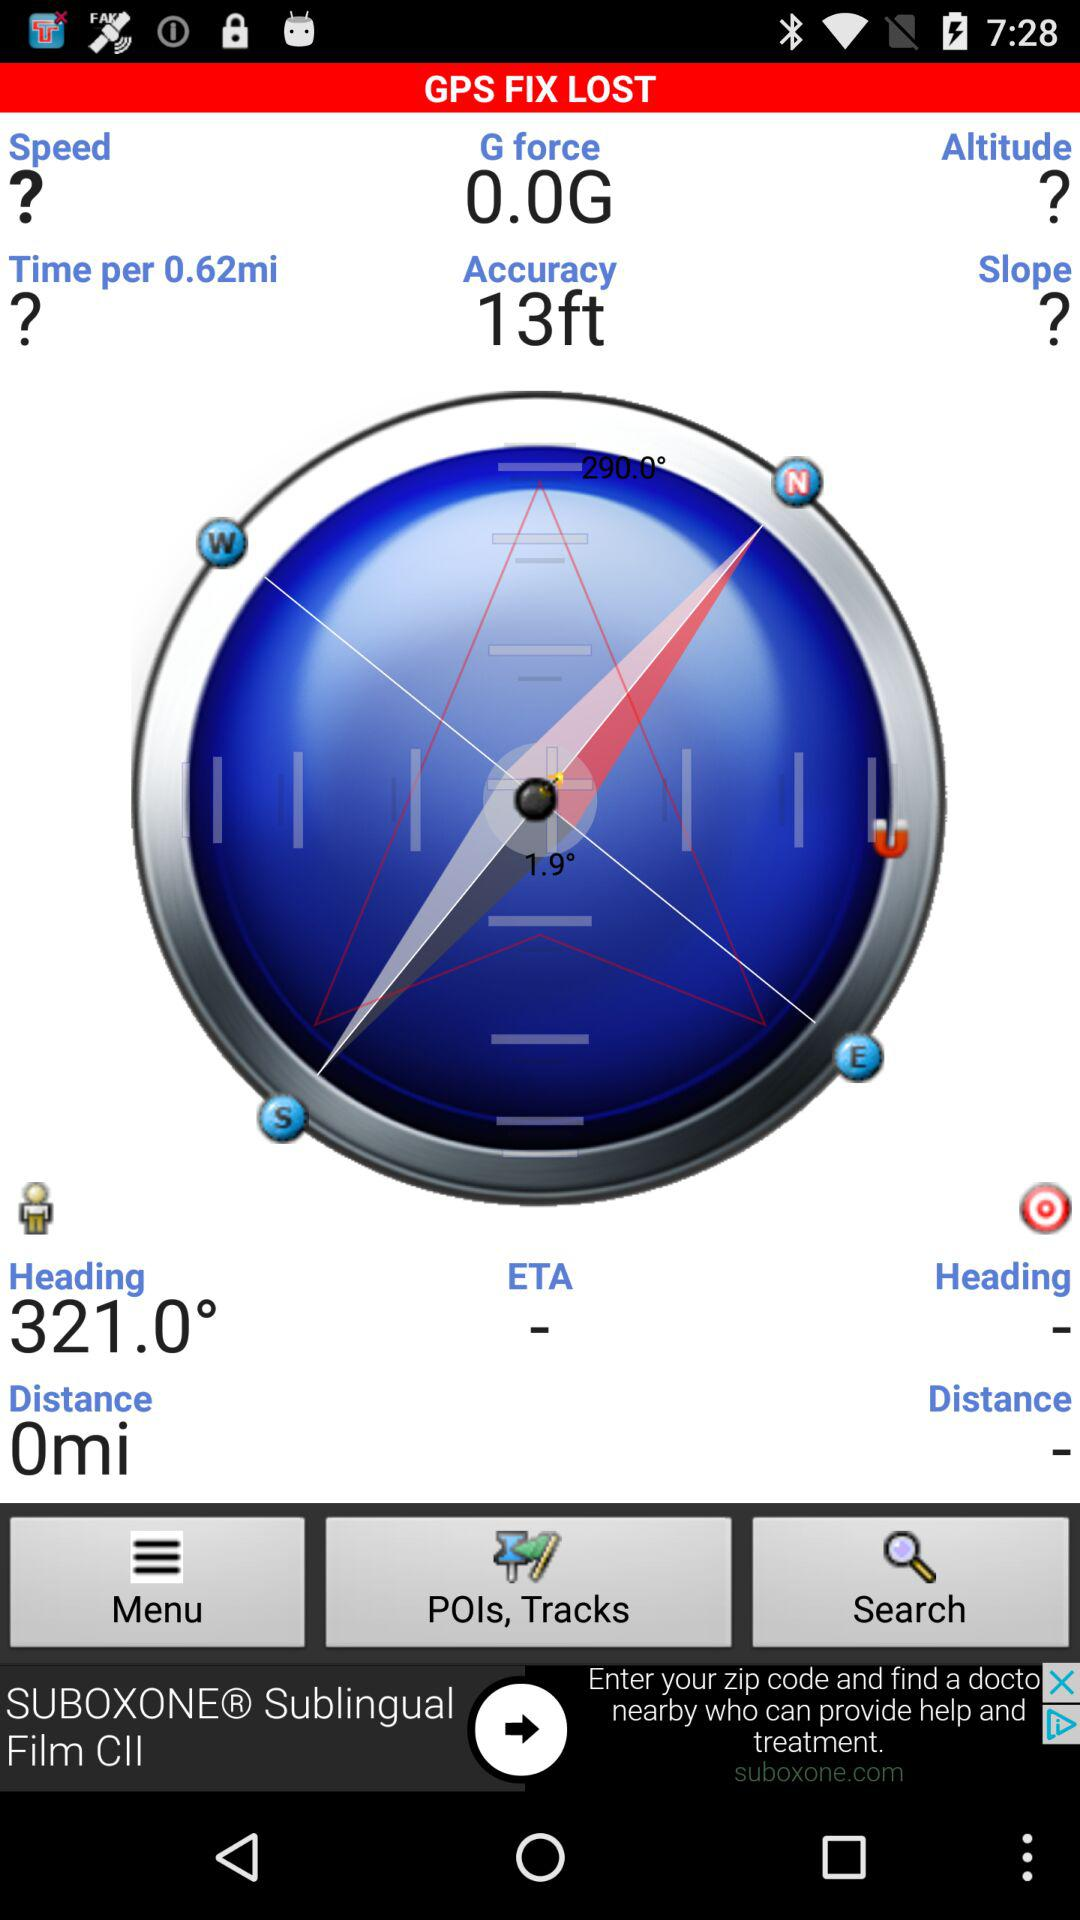What is the application name? The application name is "GPS FIX LOST". 